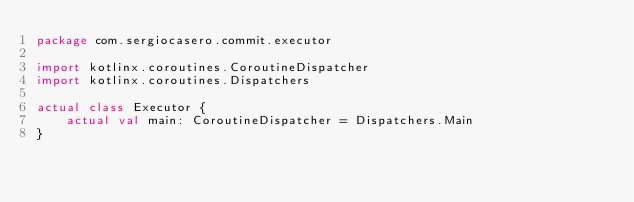<code> <loc_0><loc_0><loc_500><loc_500><_Kotlin_>package com.sergiocasero.commit.executor

import kotlinx.coroutines.CoroutineDispatcher
import kotlinx.coroutines.Dispatchers

actual class Executor {
    actual val main: CoroutineDispatcher = Dispatchers.Main
}</code> 